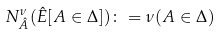Convert formula to latex. <formula><loc_0><loc_0><loc_500><loc_500>N ^ { \nu } _ { \hat { A } } ( \hat { E } [ A \in \Delta ] ) \colon = \nu ( A \in \Delta )</formula> 